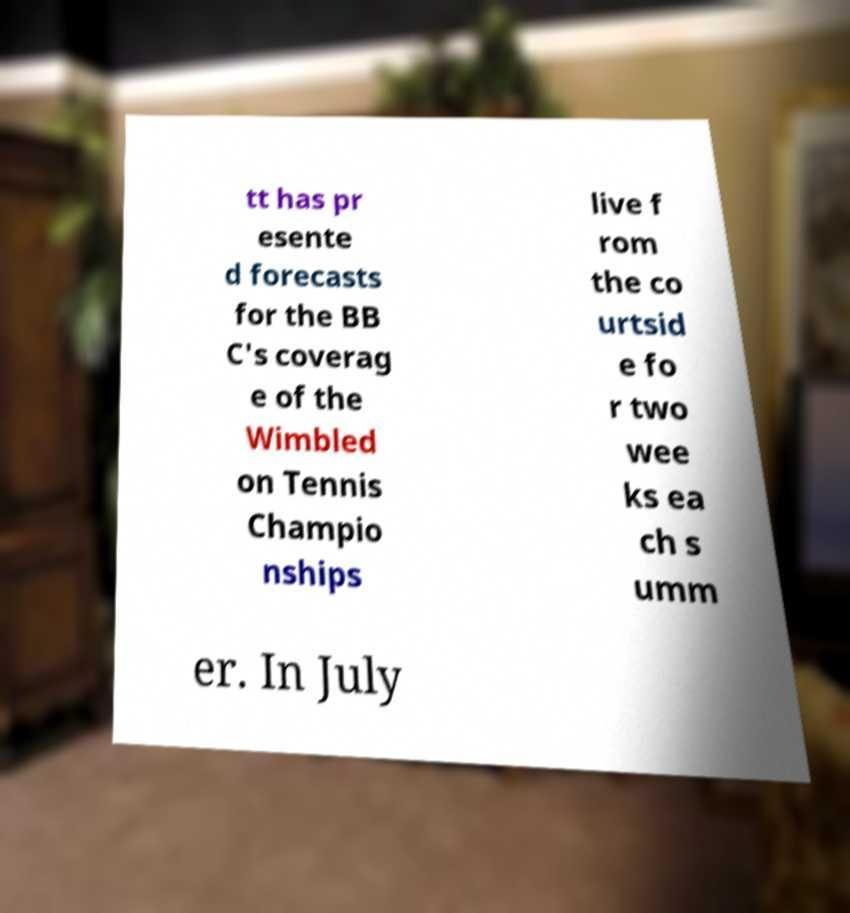Could you extract and type out the text from this image? tt has pr esente d forecasts for the BB C's coverag e of the Wimbled on Tennis Champio nships live f rom the co urtsid e fo r two wee ks ea ch s umm er. In July 